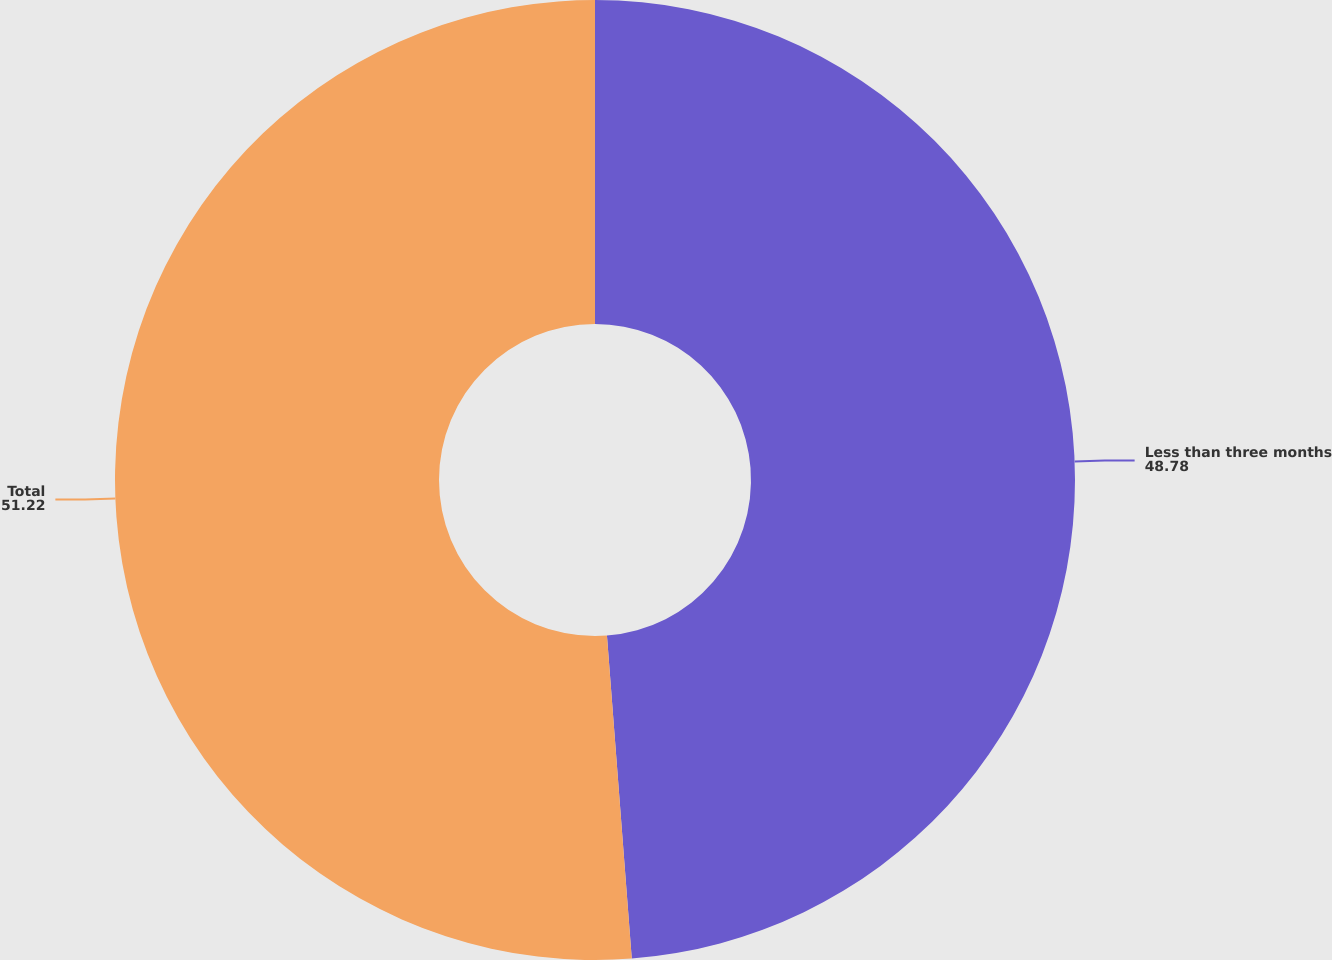<chart> <loc_0><loc_0><loc_500><loc_500><pie_chart><fcel>Less than three months<fcel>Total<nl><fcel>48.78%<fcel>51.22%<nl></chart> 